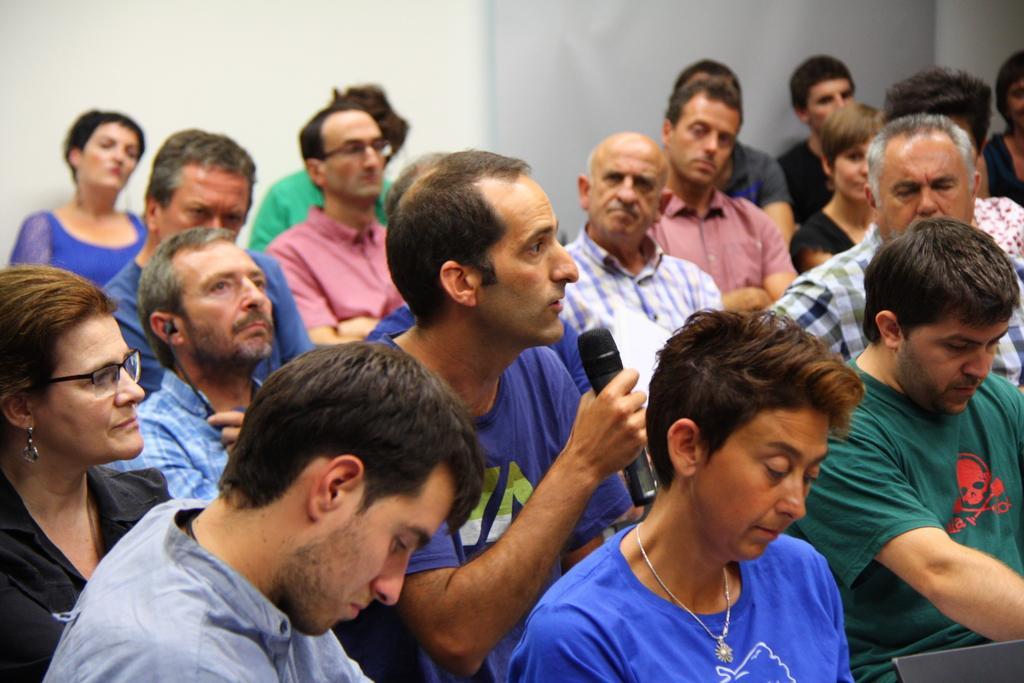Could you give a brief overview of what you see in this image? In this picture there are few people sitting where one among them is holding a mic in his hand and speaking in front of it. 